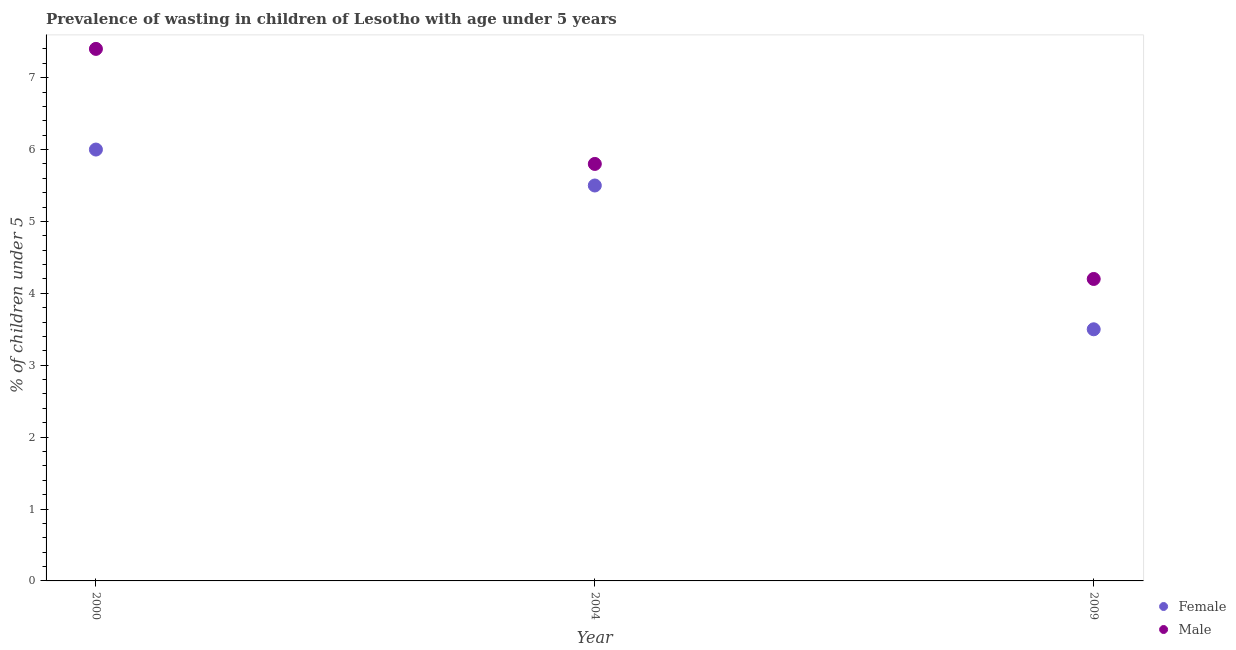Is the number of dotlines equal to the number of legend labels?
Ensure brevity in your answer.  Yes. What is the percentage of undernourished male children in 2000?
Provide a short and direct response. 7.4. Across all years, what is the maximum percentage of undernourished female children?
Your answer should be compact. 6. Across all years, what is the minimum percentage of undernourished male children?
Ensure brevity in your answer.  4.2. In which year was the percentage of undernourished female children minimum?
Provide a succinct answer. 2009. What is the total percentage of undernourished female children in the graph?
Offer a terse response. 15. What is the difference between the percentage of undernourished male children in 2004 and the percentage of undernourished female children in 2009?
Your answer should be compact. 2.3. What is the average percentage of undernourished male children per year?
Your answer should be compact. 5.8. In the year 2000, what is the difference between the percentage of undernourished male children and percentage of undernourished female children?
Make the answer very short. 1.4. What is the ratio of the percentage of undernourished male children in 2004 to that in 2009?
Keep it short and to the point. 1.38. Is the difference between the percentage of undernourished male children in 2000 and 2004 greater than the difference between the percentage of undernourished female children in 2000 and 2004?
Provide a succinct answer. Yes. In how many years, is the percentage of undernourished female children greater than the average percentage of undernourished female children taken over all years?
Ensure brevity in your answer.  2. How many dotlines are there?
Provide a succinct answer. 2. How many years are there in the graph?
Offer a terse response. 3. Are the values on the major ticks of Y-axis written in scientific E-notation?
Your answer should be compact. No. Does the graph contain grids?
Provide a succinct answer. No. How many legend labels are there?
Ensure brevity in your answer.  2. How are the legend labels stacked?
Offer a very short reply. Vertical. What is the title of the graph?
Provide a short and direct response. Prevalence of wasting in children of Lesotho with age under 5 years. What is the label or title of the Y-axis?
Your answer should be very brief.  % of children under 5. What is the  % of children under 5 in Female in 2000?
Offer a terse response. 6. What is the  % of children under 5 of Male in 2000?
Offer a very short reply. 7.4. What is the  % of children under 5 in Female in 2004?
Your response must be concise. 5.5. What is the  % of children under 5 in Male in 2004?
Ensure brevity in your answer.  5.8. What is the  % of children under 5 of Female in 2009?
Your answer should be very brief. 3.5. What is the  % of children under 5 of Male in 2009?
Ensure brevity in your answer.  4.2. Across all years, what is the maximum  % of children under 5 in Female?
Offer a very short reply. 6. Across all years, what is the maximum  % of children under 5 in Male?
Provide a succinct answer. 7.4. Across all years, what is the minimum  % of children under 5 in Female?
Offer a terse response. 3.5. Across all years, what is the minimum  % of children under 5 of Male?
Provide a succinct answer. 4.2. What is the total  % of children under 5 in Female in the graph?
Keep it short and to the point. 15. What is the difference between the  % of children under 5 of Female in 2000 and that in 2004?
Your answer should be compact. 0.5. What is the difference between the  % of children under 5 of Female in 2000 and that in 2009?
Your response must be concise. 2.5. What is the difference between the  % of children under 5 of Male in 2000 and that in 2009?
Your answer should be very brief. 3.2. What is the difference between the  % of children under 5 in Female in 2004 and that in 2009?
Give a very brief answer. 2. What is the difference between the  % of children under 5 in Male in 2004 and that in 2009?
Keep it short and to the point. 1.6. What is the difference between the  % of children under 5 of Female in 2000 and the  % of children under 5 of Male in 2004?
Keep it short and to the point. 0.2. What is the difference between the  % of children under 5 of Female in 2004 and the  % of children under 5 of Male in 2009?
Your response must be concise. 1.3. In the year 2000, what is the difference between the  % of children under 5 in Female and  % of children under 5 in Male?
Your answer should be very brief. -1.4. In the year 2004, what is the difference between the  % of children under 5 in Female and  % of children under 5 in Male?
Ensure brevity in your answer.  -0.3. What is the ratio of the  % of children under 5 in Male in 2000 to that in 2004?
Provide a short and direct response. 1.28. What is the ratio of the  % of children under 5 of Female in 2000 to that in 2009?
Provide a short and direct response. 1.71. What is the ratio of the  % of children under 5 in Male in 2000 to that in 2009?
Keep it short and to the point. 1.76. What is the ratio of the  % of children under 5 of Female in 2004 to that in 2009?
Offer a very short reply. 1.57. What is the ratio of the  % of children under 5 in Male in 2004 to that in 2009?
Your answer should be compact. 1.38. What is the difference between the highest and the second highest  % of children under 5 of Female?
Offer a very short reply. 0.5. What is the difference between the highest and the second highest  % of children under 5 of Male?
Your answer should be very brief. 1.6. What is the difference between the highest and the lowest  % of children under 5 of Female?
Provide a succinct answer. 2.5. 